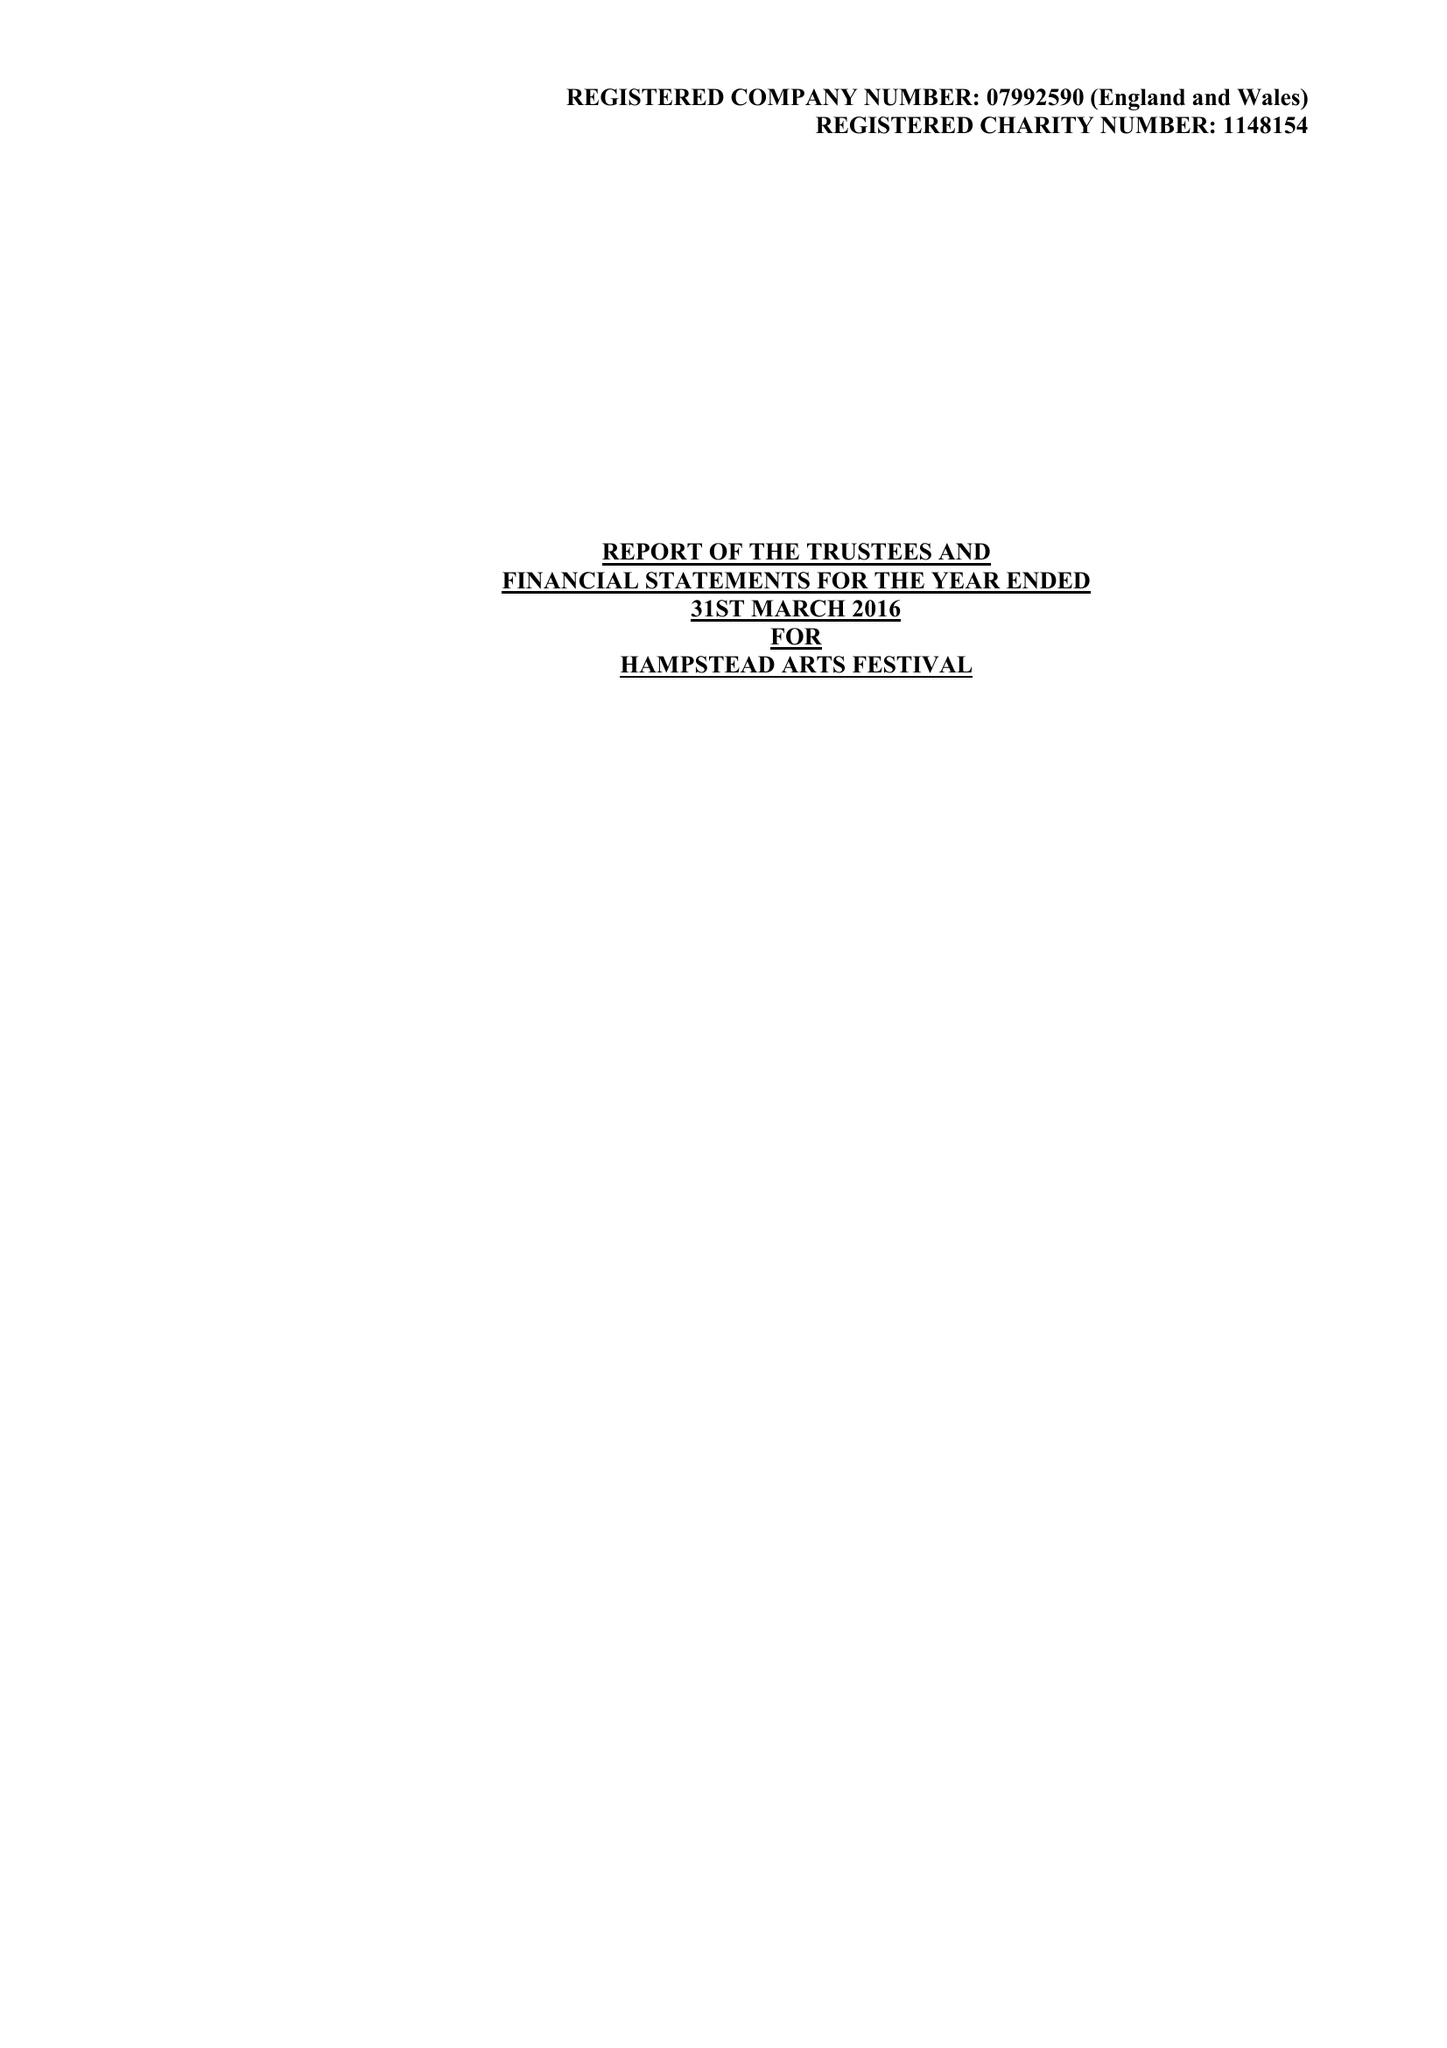What is the value for the address__street_line?
Answer the question using a single word or phrase. 31/33 COLLEGE ROAD 